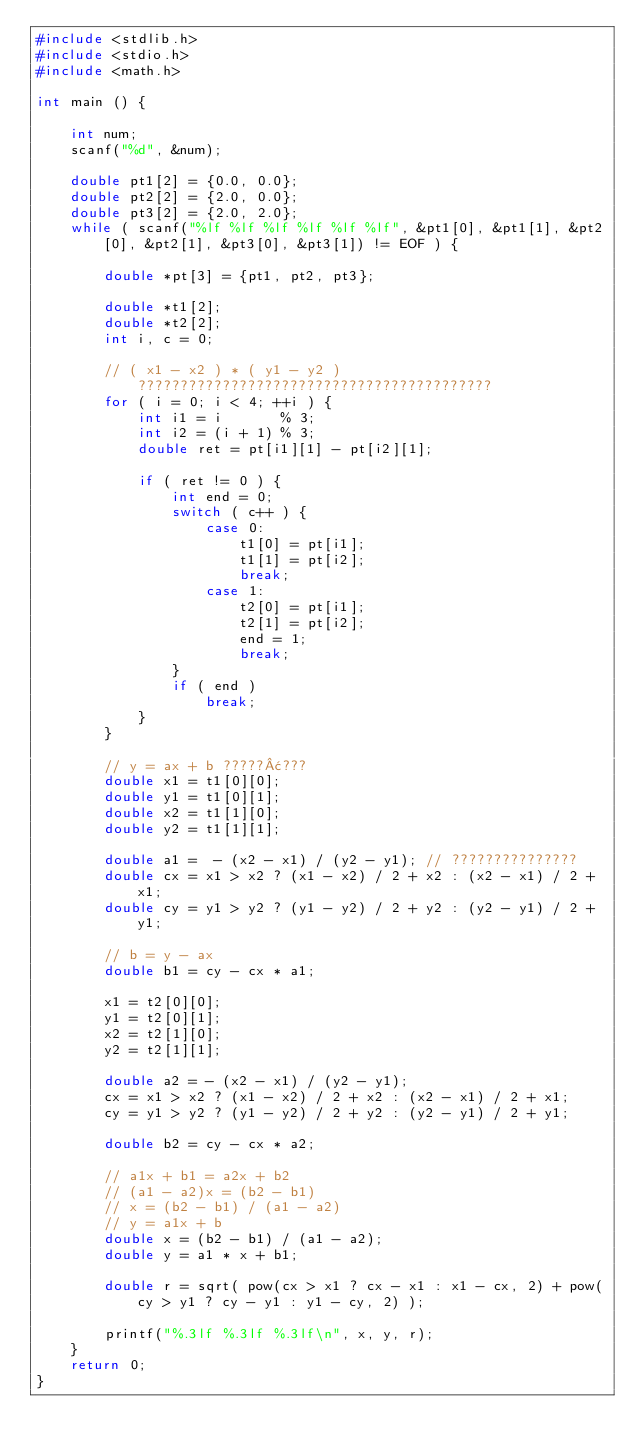<code> <loc_0><loc_0><loc_500><loc_500><_C_>#include <stdlib.h>
#include <stdio.h>
#include <math.h>

int main () {

    int num;
    scanf("%d", &num);

    double pt1[2] = {0.0, 0.0};
    double pt2[2] = {2.0, 0.0};
    double pt3[2] = {2.0, 2.0};
    while ( scanf("%lf %lf %lf %lf %lf %lf", &pt1[0], &pt1[1], &pt2[0], &pt2[1], &pt3[0], &pt3[1]) != EOF ) {

        double *pt[3] = {pt1, pt2, pt3};

        double *t1[2];
        double *t2[2];
        int i, c = 0;

        // ( x1 - x2 ) * ( y1 - y2 ) ??????????????????????????????????????????
        for ( i = 0; i < 4; ++i ) {
            int i1 = i       % 3;
            int i2 = (i + 1) % 3;
            double ret = pt[i1][1] - pt[i2][1];

            if ( ret != 0 ) {
                int end = 0;
                switch ( c++ ) {
                    case 0:
                        t1[0] = pt[i1];
                        t1[1] = pt[i2];
                        break;
                    case 1:
                        t2[0] = pt[i1];
                        t2[1] = pt[i2];
                        end = 1;
                        break;
                }
                if ( end )
                    break;
            }
        }

        // y = ax + b ?????¢???
        double x1 = t1[0][0];
        double y1 = t1[0][1];
        double x2 = t1[1][0];
        double y2 = t1[1][1];

        double a1 =  - (x2 - x1) / (y2 - y1); // ???????????????
        double cx = x1 > x2 ? (x1 - x2) / 2 + x2 : (x2 - x1) / 2 + x1;
        double cy = y1 > y2 ? (y1 - y2) / 2 + y2 : (y2 - y1) / 2 + y1;

        // b = y - ax
        double b1 = cy - cx * a1;

        x1 = t2[0][0];
        y1 = t2[0][1];
        x2 = t2[1][0];
        y2 = t2[1][1];

        double a2 = - (x2 - x1) / (y2 - y1);
        cx = x1 > x2 ? (x1 - x2) / 2 + x2 : (x2 - x1) / 2 + x1;
        cy = y1 > y2 ? (y1 - y2) / 2 + y2 : (y2 - y1) / 2 + y1;

        double b2 = cy - cx * a2;

        // a1x + b1 = a2x + b2
        // (a1 - a2)x = (b2 - b1)
        // x = (b2 - b1) / (a1 - a2)
        // y = a1x + b
        double x = (b2 - b1) / (a1 - a2);
        double y = a1 * x + b1;

        double r = sqrt( pow(cx > x1 ? cx - x1 : x1 - cx, 2) + pow(cy > y1 ? cy - y1 : y1 - cy, 2) );

        printf("%.3lf %.3lf %.3lf\n", x, y, r);
    }
    return 0;
}</code> 